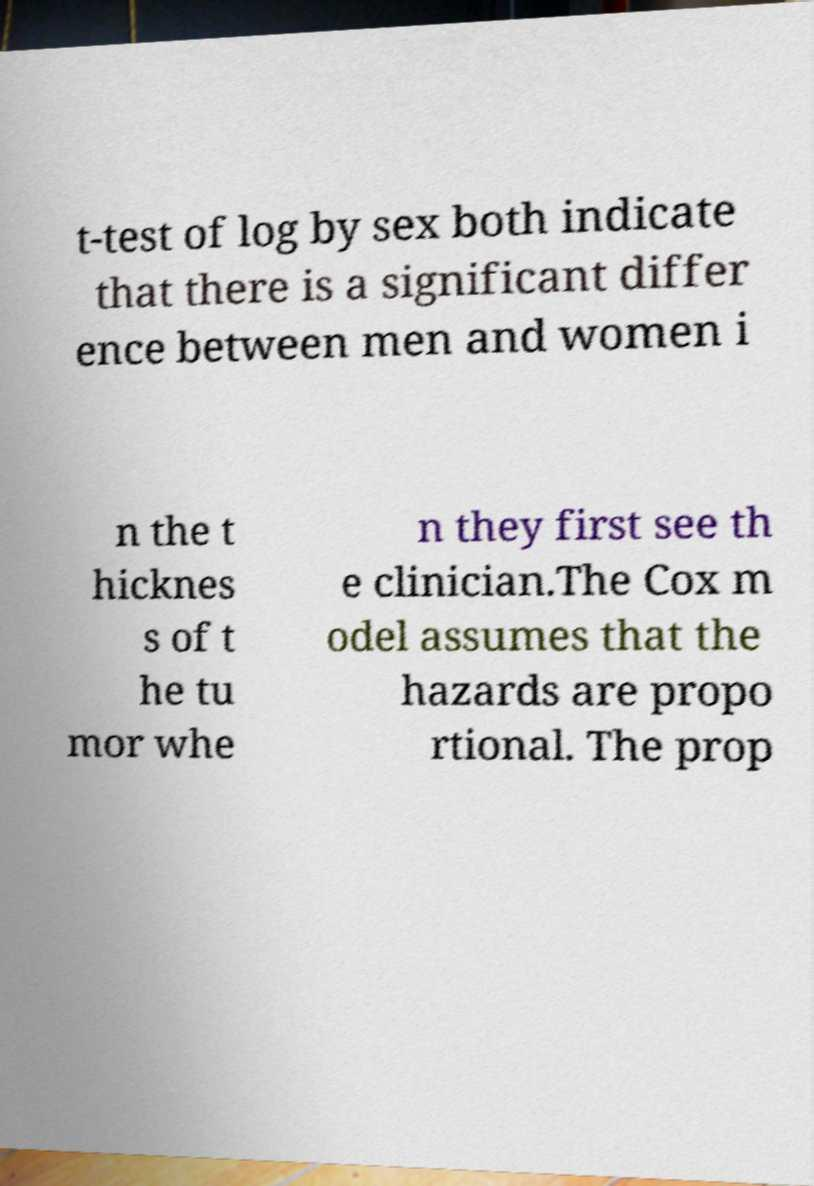Could you extract and type out the text from this image? t-test of log by sex both indicate that there is a significant differ ence between men and women i n the t hicknes s of t he tu mor whe n they first see th e clinician.The Cox m odel assumes that the hazards are propo rtional. The prop 